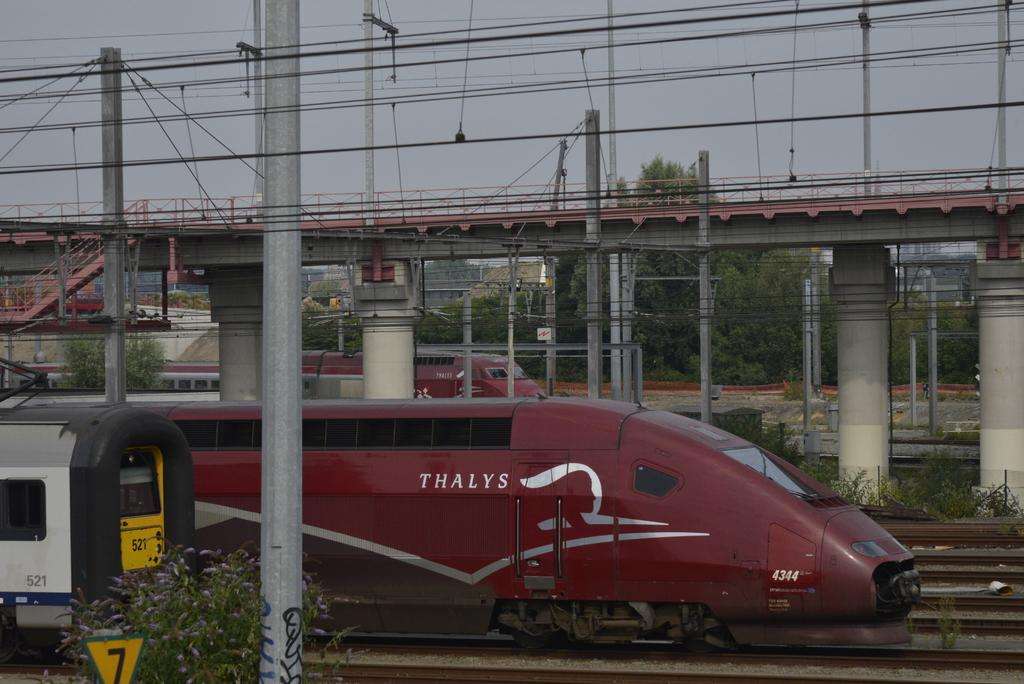<image>
Give a short and clear explanation of the subsequent image. A red bullet train says Thalys on the side. 